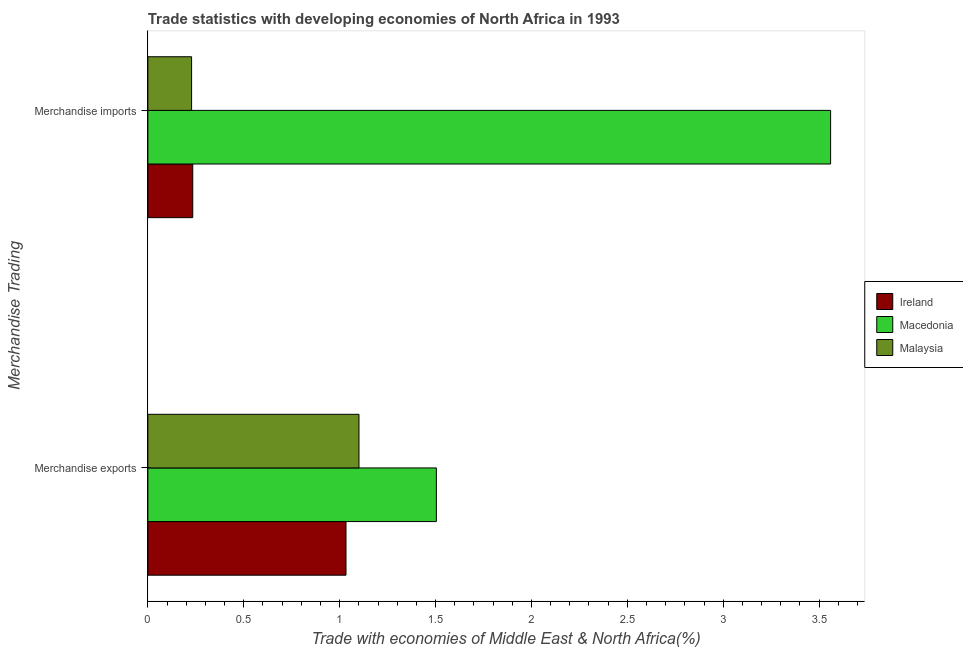How many different coloured bars are there?
Provide a short and direct response. 3. Are the number of bars on each tick of the Y-axis equal?
Ensure brevity in your answer.  Yes. What is the label of the 1st group of bars from the top?
Provide a succinct answer. Merchandise imports. What is the merchandise exports in Malaysia?
Give a very brief answer. 1.1. Across all countries, what is the maximum merchandise exports?
Make the answer very short. 1.5. Across all countries, what is the minimum merchandise imports?
Offer a terse response. 0.23. In which country was the merchandise imports maximum?
Your response must be concise. Macedonia. In which country was the merchandise exports minimum?
Offer a very short reply. Ireland. What is the total merchandise exports in the graph?
Your answer should be compact. 3.64. What is the difference between the merchandise imports in Malaysia and that in Ireland?
Give a very brief answer. -0.01. What is the difference between the merchandise imports in Malaysia and the merchandise exports in Macedonia?
Your response must be concise. -1.28. What is the average merchandise exports per country?
Give a very brief answer. 1.21. What is the difference between the merchandise imports and merchandise exports in Malaysia?
Make the answer very short. -0.87. What is the ratio of the merchandise imports in Ireland to that in Macedonia?
Your answer should be compact. 0.07. Is the merchandise imports in Ireland less than that in Macedonia?
Your answer should be very brief. Yes. What does the 1st bar from the top in Merchandise imports represents?
Your answer should be very brief. Malaysia. What does the 3rd bar from the bottom in Merchandise exports represents?
Give a very brief answer. Malaysia. How many bars are there?
Give a very brief answer. 6. How many countries are there in the graph?
Your answer should be very brief. 3. Are the values on the major ticks of X-axis written in scientific E-notation?
Make the answer very short. No. Does the graph contain grids?
Give a very brief answer. No. How are the legend labels stacked?
Offer a very short reply. Vertical. What is the title of the graph?
Make the answer very short. Trade statistics with developing economies of North Africa in 1993. What is the label or title of the X-axis?
Provide a short and direct response. Trade with economies of Middle East & North Africa(%). What is the label or title of the Y-axis?
Offer a terse response. Merchandise Trading. What is the Trade with economies of Middle East & North Africa(%) in Ireland in Merchandise exports?
Your response must be concise. 1.03. What is the Trade with economies of Middle East & North Africa(%) of Macedonia in Merchandise exports?
Provide a short and direct response. 1.5. What is the Trade with economies of Middle East & North Africa(%) in Malaysia in Merchandise exports?
Make the answer very short. 1.1. What is the Trade with economies of Middle East & North Africa(%) of Ireland in Merchandise imports?
Your answer should be compact. 0.23. What is the Trade with economies of Middle East & North Africa(%) of Macedonia in Merchandise imports?
Your answer should be compact. 3.56. What is the Trade with economies of Middle East & North Africa(%) of Malaysia in Merchandise imports?
Keep it short and to the point. 0.23. Across all Merchandise Trading, what is the maximum Trade with economies of Middle East & North Africa(%) in Ireland?
Provide a succinct answer. 1.03. Across all Merchandise Trading, what is the maximum Trade with economies of Middle East & North Africa(%) in Macedonia?
Keep it short and to the point. 3.56. Across all Merchandise Trading, what is the maximum Trade with economies of Middle East & North Africa(%) of Malaysia?
Provide a short and direct response. 1.1. Across all Merchandise Trading, what is the minimum Trade with economies of Middle East & North Africa(%) of Ireland?
Your answer should be very brief. 0.23. Across all Merchandise Trading, what is the minimum Trade with economies of Middle East & North Africa(%) in Macedonia?
Keep it short and to the point. 1.5. Across all Merchandise Trading, what is the minimum Trade with economies of Middle East & North Africa(%) in Malaysia?
Make the answer very short. 0.23. What is the total Trade with economies of Middle East & North Africa(%) of Ireland in the graph?
Provide a succinct answer. 1.27. What is the total Trade with economies of Middle East & North Africa(%) in Macedonia in the graph?
Make the answer very short. 5.06. What is the total Trade with economies of Middle East & North Africa(%) in Malaysia in the graph?
Offer a very short reply. 1.33. What is the difference between the Trade with economies of Middle East & North Africa(%) in Ireland in Merchandise exports and that in Merchandise imports?
Offer a very short reply. 0.8. What is the difference between the Trade with economies of Middle East & North Africa(%) of Macedonia in Merchandise exports and that in Merchandise imports?
Give a very brief answer. -2.06. What is the difference between the Trade with economies of Middle East & North Africa(%) in Malaysia in Merchandise exports and that in Merchandise imports?
Keep it short and to the point. 0.87. What is the difference between the Trade with economies of Middle East & North Africa(%) of Ireland in Merchandise exports and the Trade with economies of Middle East & North Africa(%) of Macedonia in Merchandise imports?
Your response must be concise. -2.53. What is the difference between the Trade with economies of Middle East & North Africa(%) in Ireland in Merchandise exports and the Trade with economies of Middle East & North Africa(%) in Malaysia in Merchandise imports?
Your response must be concise. 0.81. What is the difference between the Trade with economies of Middle East & North Africa(%) of Macedonia in Merchandise exports and the Trade with economies of Middle East & North Africa(%) of Malaysia in Merchandise imports?
Make the answer very short. 1.28. What is the average Trade with economies of Middle East & North Africa(%) in Ireland per Merchandise Trading?
Provide a succinct answer. 0.63. What is the average Trade with economies of Middle East & North Africa(%) of Macedonia per Merchandise Trading?
Your answer should be very brief. 2.53. What is the average Trade with economies of Middle East & North Africa(%) in Malaysia per Merchandise Trading?
Your response must be concise. 0.66. What is the difference between the Trade with economies of Middle East & North Africa(%) in Ireland and Trade with economies of Middle East & North Africa(%) in Macedonia in Merchandise exports?
Offer a terse response. -0.47. What is the difference between the Trade with economies of Middle East & North Africa(%) in Ireland and Trade with economies of Middle East & North Africa(%) in Malaysia in Merchandise exports?
Keep it short and to the point. -0.07. What is the difference between the Trade with economies of Middle East & North Africa(%) in Macedonia and Trade with economies of Middle East & North Africa(%) in Malaysia in Merchandise exports?
Your response must be concise. 0.4. What is the difference between the Trade with economies of Middle East & North Africa(%) in Ireland and Trade with economies of Middle East & North Africa(%) in Macedonia in Merchandise imports?
Your answer should be compact. -3.33. What is the difference between the Trade with economies of Middle East & North Africa(%) of Ireland and Trade with economies of Middle East & North Africa(%) of Malaysia in Merchandise imports?
Offer a terse response. 0.01. What is the difference between the Trade with economies of Middle East & North Africa(%) in Macedonia and Trade with economies of Middle East & North Africa(%) in Malaysia in Merchandise imports?
Offer a very short reply. 3.33. What is the ratio of the Trade with economies of Middle East & North Africa(%) of Ireland in Merchandise exports to that in Merchandise imports?
Ensure brevity in your answer.  4.41. What is the ratio of the Trade with economies of Middle East & North Africa(%) in Macedonia in Merchandise exports to that in Merchandise imports?
Provide a succinct answer. 0.42. What is the ratio of the Trade with economies of Middle East & North Africa(%) in Malaysia in Merchandise exports to that in Merchandise imports?
Ensure brevity in your answer.  4.83. What is the difference between the highest and the second highest Trade with economies of Middle East & North Africa(%) in Ireland?
Offer a terse response. 0.8. What is the difference between the highest and the second highest Trade with economies of Middle East & North Africa(%) in Macedonia?
Provide a short and direct response. 2.06. What is the difference between the highest and the second highest Trade with economies of Middle East & North Africa(%) in Malaysia?
Offer a very short reply. 0.87. What is the difference between the highest and the lowest Trade with economies of Middle East & North Africa(%) in Ireland?
Your answer should be very brief. 0.8. What is the difference between the highest and the lowest Trade with economies of Middle East & North Africa(%) in Macedonia?
Your answer should be very brief. 2.06. What is the difference between the highest and the lowest Trade with economies of Middle East & North Africa(%) in Malaysia?
Make the answer very short. 0.87. 